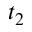Convert formula to latex. <formula><loc_0><loc_0><loc_500><loc_500>t _ { 2 }</formula> 